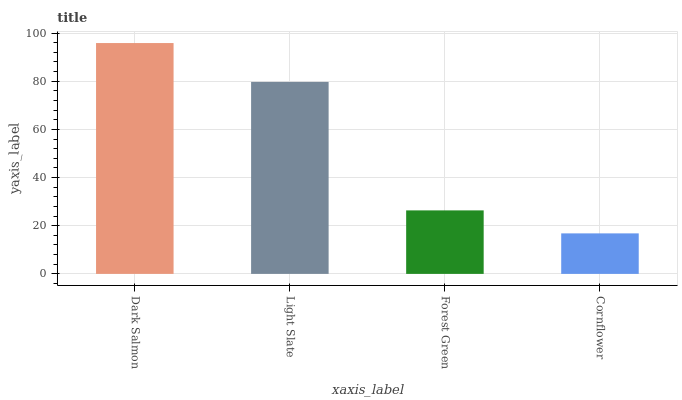Is Cornflower the minimum?
Answer yes or no. Yes. Is Dark Salmon the maximum?
Answer yes or no. Yes. Is Light Slate the minimum?
Answer yes or no. No. Is Light Slate the maximum?
Answer yes or no. No. Is Dark Salmon greater than Light Slate?
Answer yes or no. Yes. Is Light Slate less than Dark Salmon?
Answer yes or no. Yes. Is Light Slate greater than Dark Salmon?
Answer yes or no. No. Is Dark Salmon less than Light Slate?
Answer yes or no. No. Is Light Slate the high median?
Answer yes or no. Yes. Is Forest Green the low median?
Answer yes or no. Yes. Is Cornflower the high median?
Answer yes or no. No. Is Light Slate the low median?
Answer yes or no. No. 